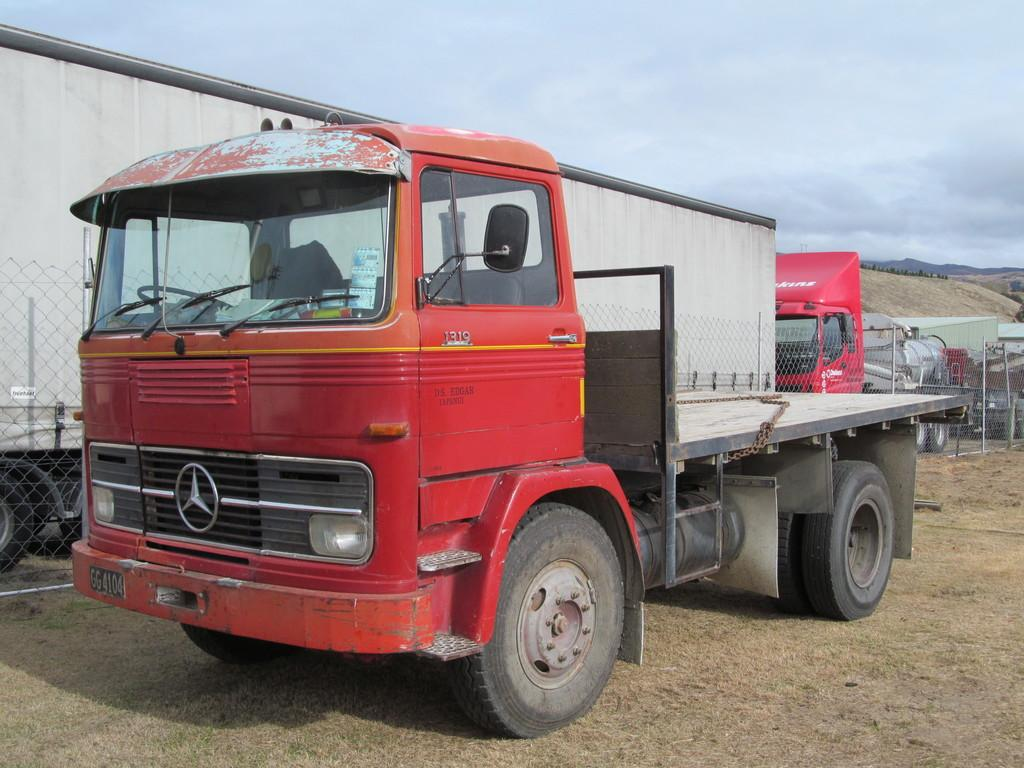What is the main subject in the center of the image? There is a vehicle in the center of the image. What else can be seen in the background of the image? There are other vehicles and a net boundary in the background of the image. How many sisters are playing with the letter in the image? There are no sisters or letters present in the image. 